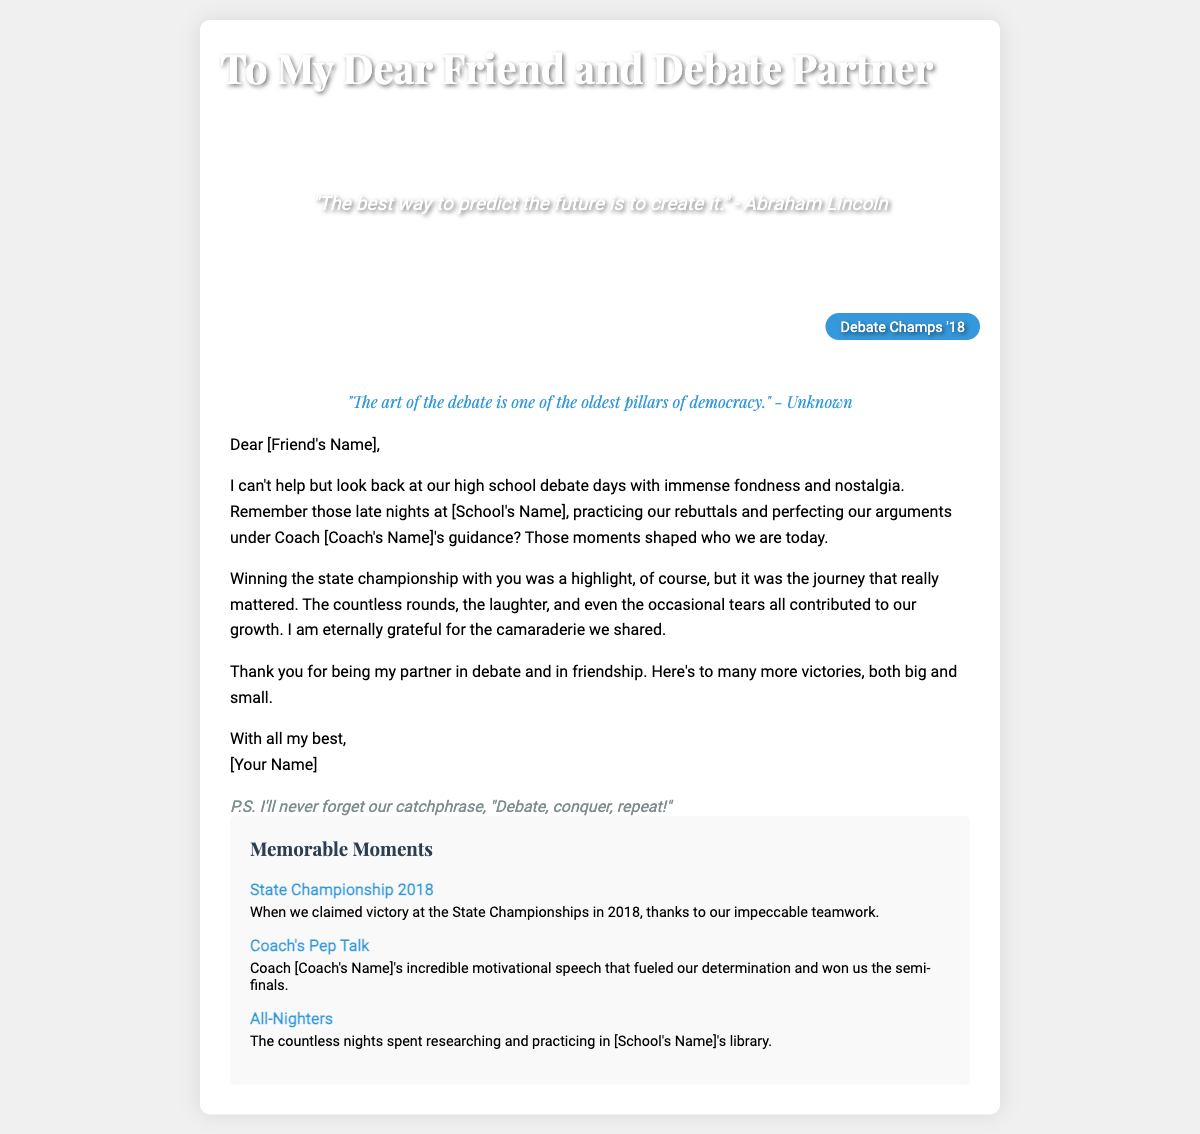What is the title of the card? The title of the card is prominently displayed at the top of the cover.
Answer: To My Dear Friend and Debate Partner Who is the quote on the cover attributed to? The quote on the cover is attributed to Abraham Lincoln.
Answer: Abraham Lincoln What year did they win the state championship? The year of the state championship is mentioned in the ribbon on the cover.
Answer: 2018 What is the document type? This document serves as a personal message to a friend, indicating it is structured as a greeting card.
Answer: Greeting card What is one memorable moment listed in the content? The content includes specific moments that highlight shared experiences in debate.
Answer: State Championship 2018 Which school did they practice at? The school where they practiced is referenced in the message section of the card.
Answer: [School's Name] What was their catchphrase mentioned in the closing? The closing features a light-hearted phrase they used during their debate days.
Answer: Debate, conquer, repeat! Who guided them during their debate practice? The individual who provided guidance during their debate practices is referenced in the message.
Answer: Coach [Coach's Name] 